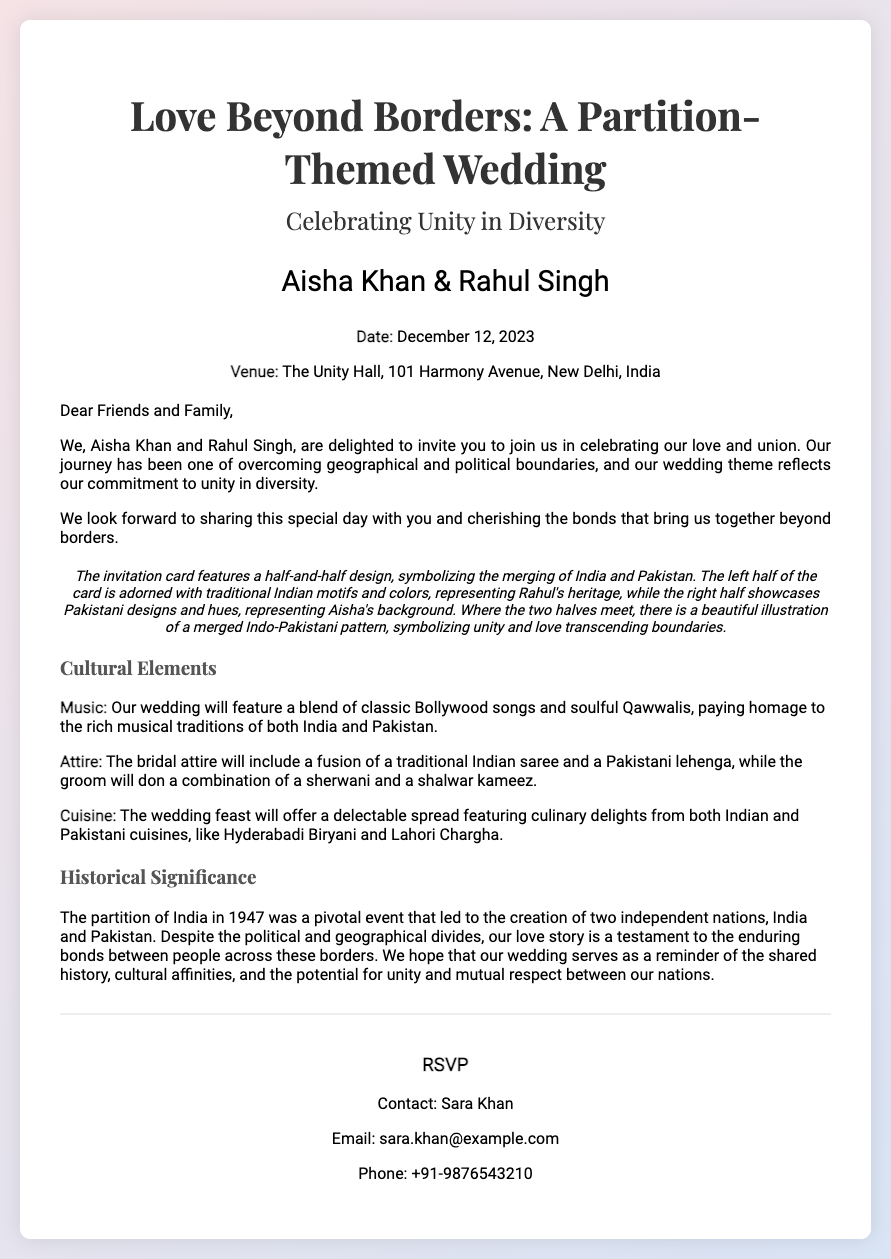What is the wedding date? The wedding date is explicitly mentioned in the details section of the invitation.
Answer: December 12, 2023 Who are the couple getting married? The names of the couple are listed at the top of the invitation.
Answer: Aisha Khan & Rahul Singh What venue is the wedding taking place? The venue location is provided in the details section of the invitation.
Answer: The Unity Hall, 101 Harmony Avenue, New Delhi, India What type of music will be featured at the wedding? Specific musical elements are mentioned in the cultural references section of the invitation.
Answer: Classic Bollywood songs and soulful Qawwalis What does the half-and-half design represent? The invitation includes a description of the design and its significance.
Answer: Merging of India and Pakistan What type of cuisine will be served at the wedding? The invitation specifies the culinary offerings in the cultural references section.
Answer: Indian and Pakistani cuisines What is the main theme of the wedding? The theme is stated in the title and throughout the invitation message.
Answer: Unity in Diversity Who to contact for RSVP? The RSVP contact details are mentioned at the end of the invitation.
Answer: Sara Khan What is the email address provided for RSVP? The RSVP section lists contact information, including an email address.
Answer: sara.khan@example.com 